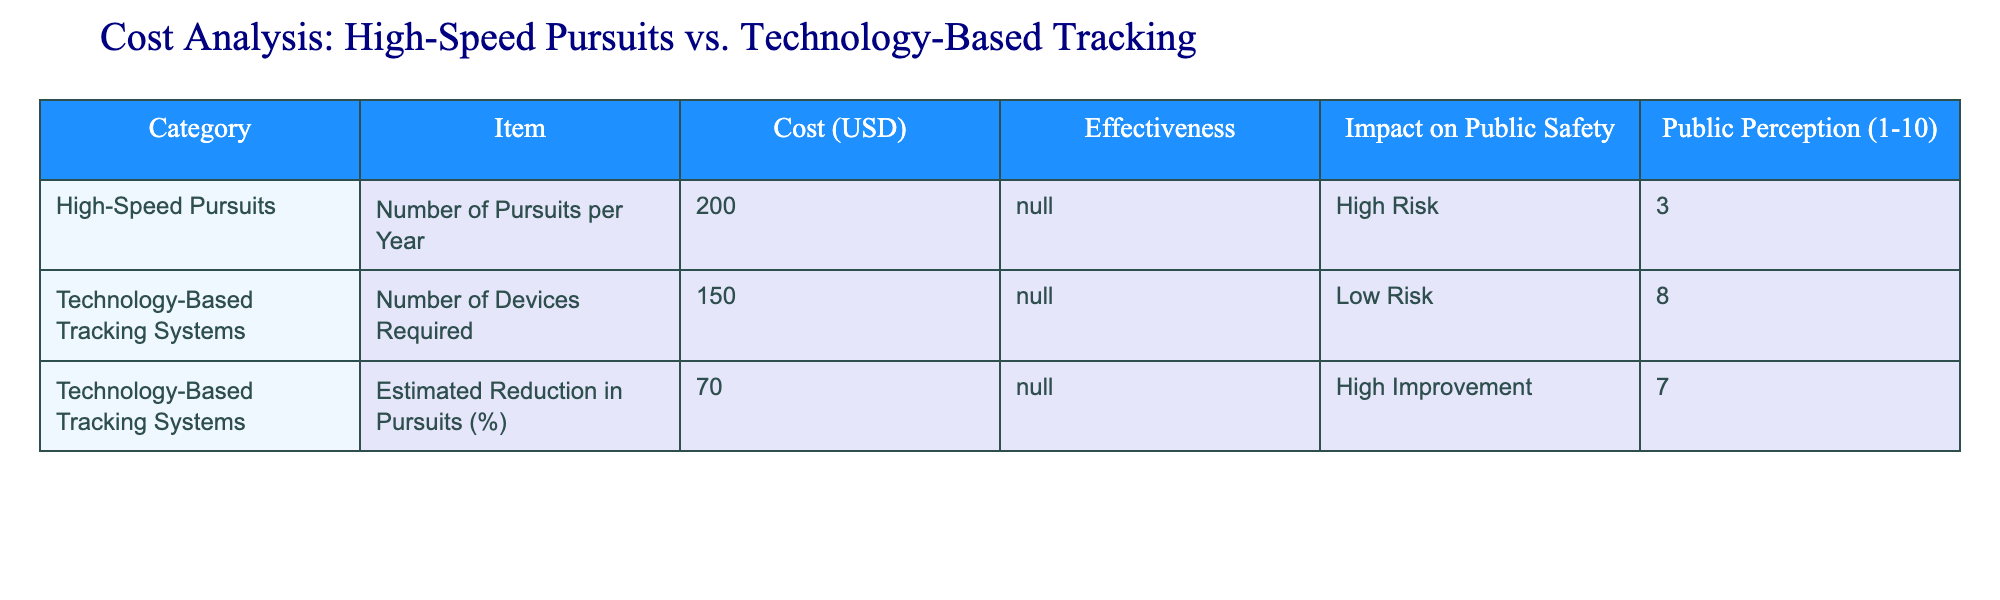What is the estimated number of high-speed pursuits per year? Referring to the table under the "High-Speed Pursuits" category in the "Item" column, the cost listed is 200, which represents the estimated number of pursuits per year.
Answer: 200 What is the cost associated with implementing technology-based tracking systems? In the "Technology-Based Tracking Systems" category, the "Item" column shows a cost of 150 for the number of devices required.
Answer: 150 Is the public perception of high-speed pursuits better than technology-based tracking systems? High-speed pursuits have a public perception rating of 3, while technology-based tracking systems have a rating of 8. Since 3 is less than 8, the perception of high-speed pursuits is not better.
Answer: No What percentage reduction in pursuits is estimated with technology-based tracking systems? The table indicates that technology-based tracking systems estimate a reduction in pursuits of 70%.
Answer: 70% How does the effectiveness of high-speed pursuits compare with technology-based tracking systems? The effectiveness column shows "N/A" for both categories, meaning no specific effectiveness measure is provided for either high-speed pursuits or technology-based tracking systems.
Answer: Not applicable What is the impact on public safety regarding high-speed pursuits and technology-based tracking systems? The impact on public safety is listed as "High Risk" for high-speed pursuits and "Low Risk" for technology-based tracking systems. This shows that high-speed pursuits have a higher risk impact.
Answer: High-risk for pursuits, low-risk for tracking systems What is the difference in public perception ratings between high-speed pursuits and technology-based tracking systems? To find the difference, subtract the public perception rating of high-speed pursuits (3) from that of technology-based tracking systems (8). This gives 8 - 3 = 5.
Answer: 5 Considering the estimated reduction in pursuits, is it justified to implement technology-based tracking systems? Since the estimated reduction in pursuits is significant at 70%, this suggests that implementing technology-based tracking systems could greatly decrease high-speed pursuits, justifying their implementation for enhanced public safety.
Answer: Yes How can we summarize the overall sentiment towards technology-based tracking systems based on public perception? With a public perception rating of 8, it suggests that there is a largely positive sentiment towards technology-based tracking systems, indicating a favorable view from the public.
Answer: Positive sentiment 